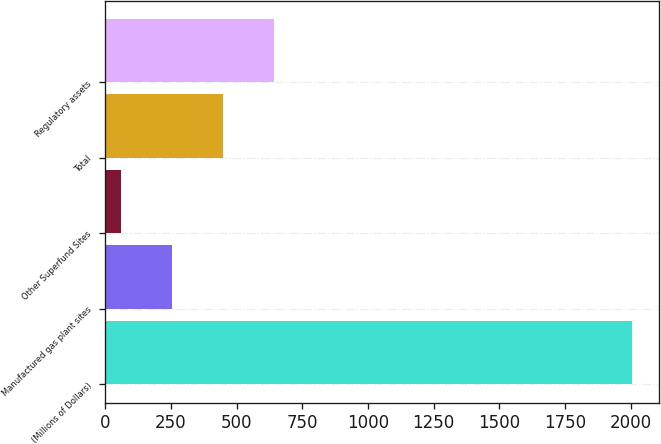Convert chart to OTSL. <chart><loc_0><loc_0><loc_500><loc_500><bar_chart><fcel>(Millions of Dollars)<fcel>Manufactured gas plant sites<fcel>Other Superfund Sites<fcel>Total<fcel>Regulatory assets<nl><fcel>2007<fcel>253.8<fcel>59<fcel>448.6<fcel>643.4<nl></chart> 